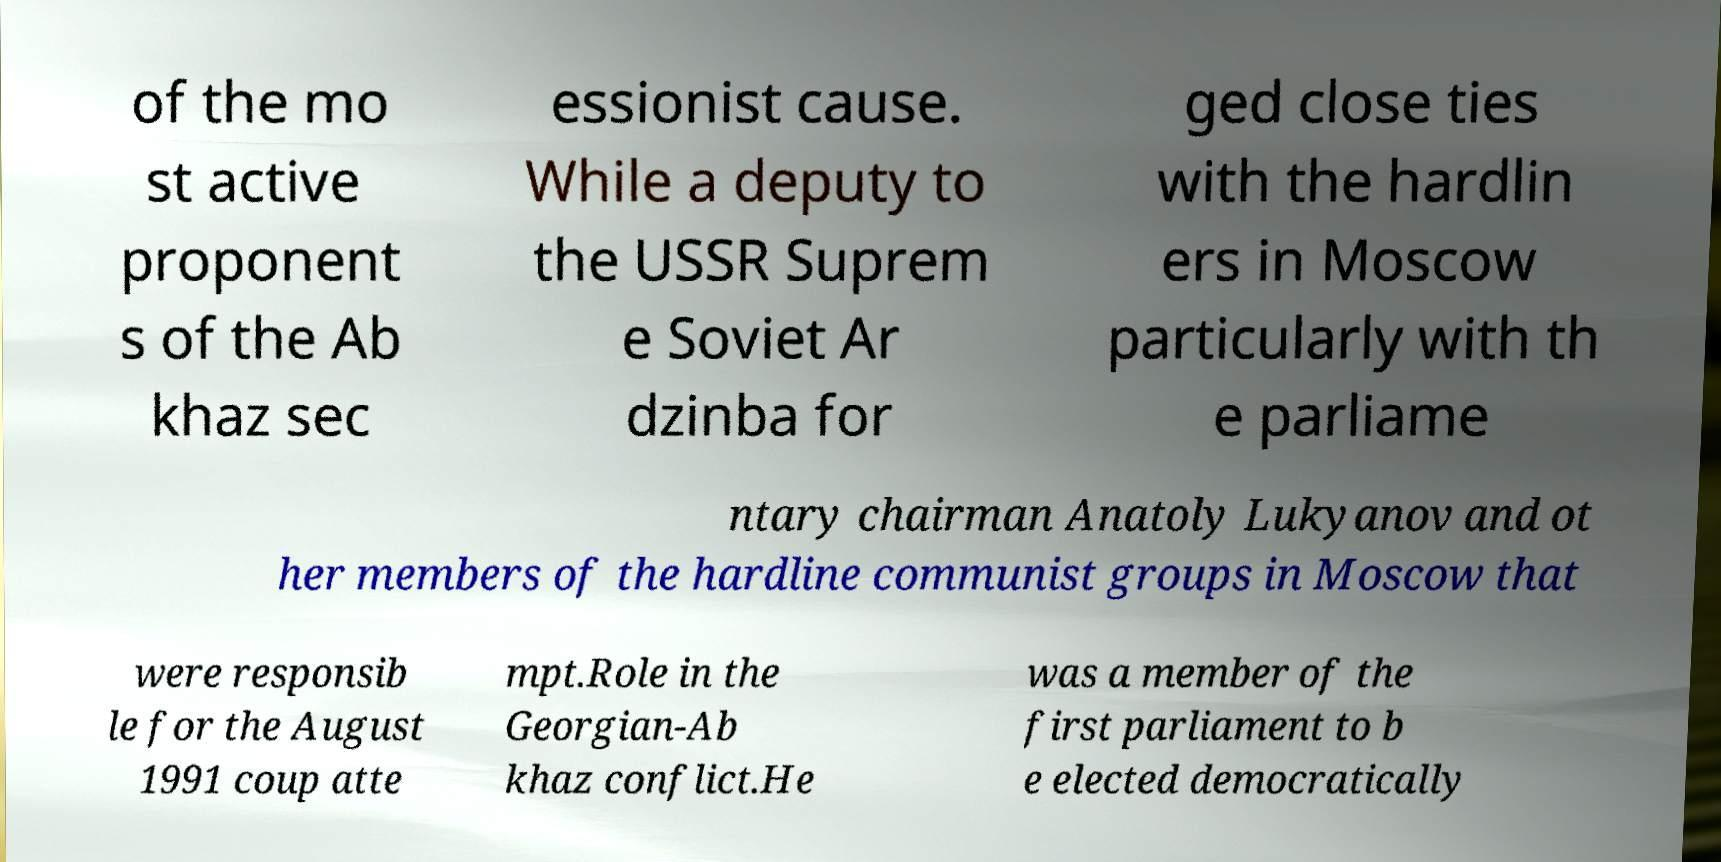Can you accurately transcribe the text from the provided image for me? of the mo st active proponent s of the Ab khaz sec essionist cause. While a deputy to the USSR Suprem e Soviet Ar dzinba for ged close ties with the hardlin ers in Moscow particularly with th e parliame ntary chairman Anatoly Lukyanov and ot her members of the hardline communist groups in Moscow that were responsib le for the August 1991 coup atte mpt.Role in the Georgian-Ab khaz conflict.He was a member of the first parliament to b e elected democratically 